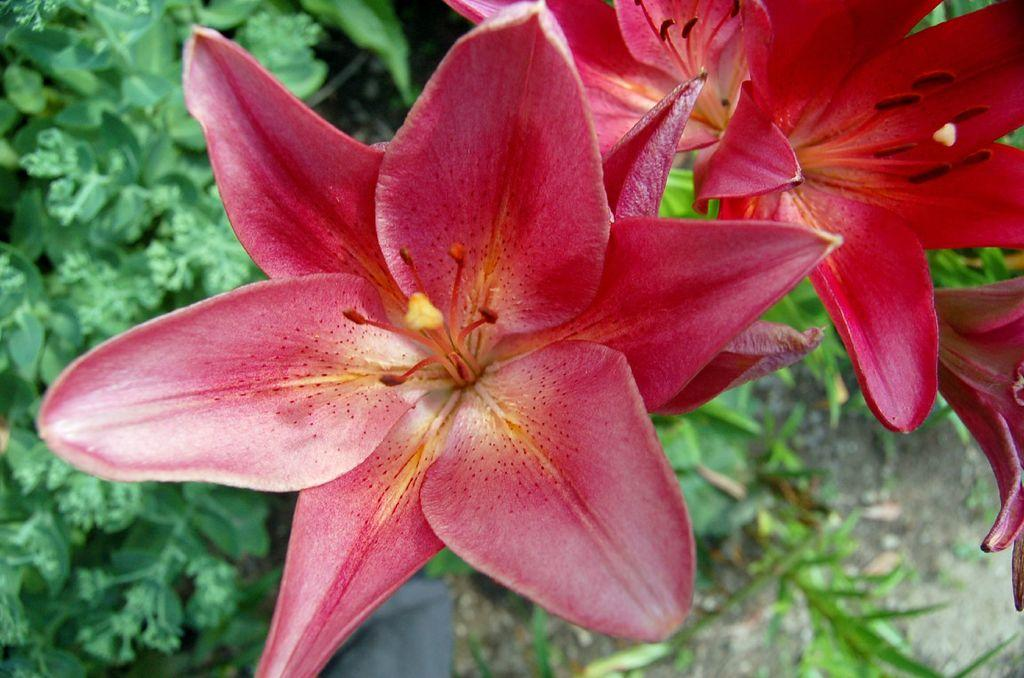What type of flora can be seen in the image? There are flowers in the image. What can be seen in the background of the image? There are green plants in the background of the image. What arithmetic problem is being solved by the cactus in the image? There is no cactus present in the image, and therefore no arithmetic problem can be solved by a cactus. 